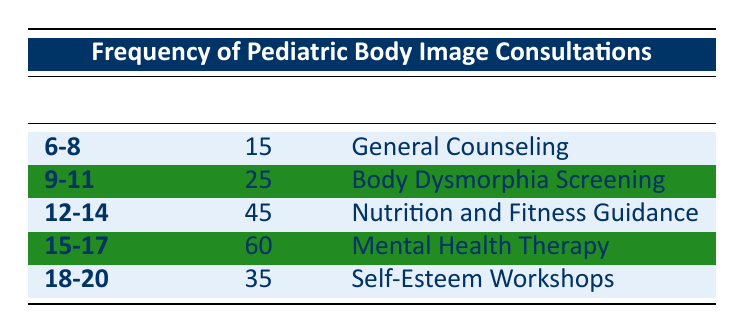What is the frequency of consultations for the age group 12-14? The table lists frequencies by age group. For the 12-14 age group, the frequency is directly provided in the table as 45.
Answer: 45 Which consultation type has the highest frequency? By examining the frequency values in the table, the highest frequency is 60, which corresponds to Mental Health Therapy.
Answer: Mental Health Therapy How many total consultations were there for all age groups combined? To find the total, sum the individual frequencies: 15 + 25 + 45 + 60 + 35 = 180.
Answer: 180 Is there a consultation type for the age group 6-8? Yes, the table indicates that there is a consultation type listed for the age group 6-8, which is General Counseling.
Answer: Yes What is the difference in frequency between the age groups 9-11 and 15-17? The frequency for 9-11 is 25, and for 15-17 it is 60. The difference is calculated as 60 - 25 = 35.
Answer: 35 What is the average frequency of consultations across all age groups? Sum the frequencies (15 + 25 + 45 + 60 + 35 = 180), then divide by the number of age groups (5): 180 / 5 = 36.
Answer: 36 Are there more consultations for age group 18-20 than for age group 9-11? The frequency for 18-20 is 35 and for 9-11 is 25. Since 35 is greater than 25, the answer is yes.
Answer: Yes What is the total frequency for the age groups involving body image issues related to Nutrition and Fitness Guidance and Mental Health Therapy? The frequencies for these consultation types are 45 (Nutrition and Fitness Guidance) and 60 (Mental Health Therapy). The total frequency is 45 + 60 = 105.
Answer: 105 Which age group has a consultation type focused on Body Dysmorphia Screening? The age group 9-11 is associated with the consultation type Body Dysmorphia Screening, as directly stated in the table.
Answer: 9-11 How many more consultations does the 15-17 age group have compared to the 18-20 age group? The frequency for 15-17 is 60 and for 18-20 is 35. The difference is 60 - 35 = 25.
Answer: 25 